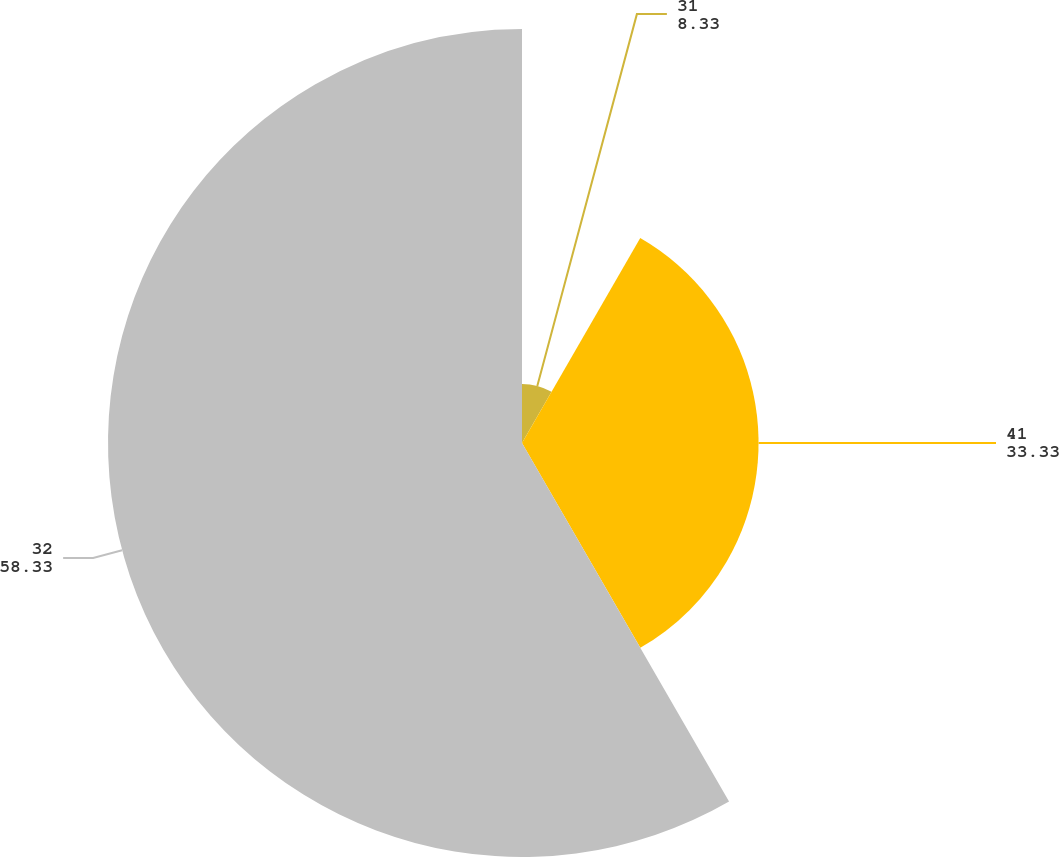Convert chart to OTSL. <chart><loc_0><loc_0><loc_500><loc_500><pie_chart><fcel>31<fcel>41<fcel>32<nl><fcel>8.33%<fcel>33.33%<fcel>58.33%<nl></chart> 